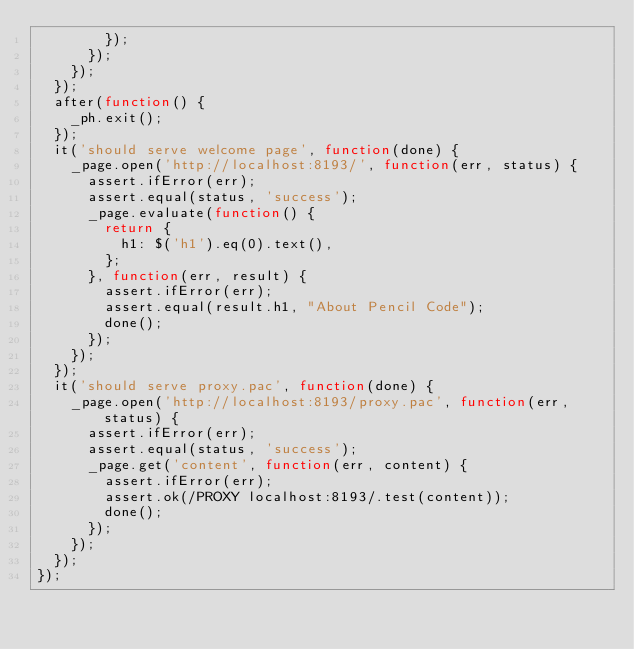<code> <loc_0><loc_0><loc_500><loc_500><_JavaScript_>        });
      });
    });
  });
  after(function() {
    _ph.exit();
  });
  it('should serve welcome page', function(done) {
    _page.open('http://localhost:8193/', function(err, status) {
      assert.ifError(err);
      assert.equal(status, 'success');
      _page.evaluate(function() {
        return {
          h1: $('h1').eq(0).text(),
        };
      }, function(err, result) {
        assert.ifError(err);
        assert.equal(result.h1, "About Pencil Code");
        done();
      });
    });
  });
  it('should serve proxy.pac', function(done) {
    _page.open('http://localhost:8193/proxy.pac', function(err, status) {
      assert.ifError(err);
      assert.equal(status, 'success');
      _page.get('content', function(err, content) {
        assert.ifError(err);
        assert.ok(/PROXY localhost:8193/.test(content));
        done();
      });
    });
  });
});
</code> 